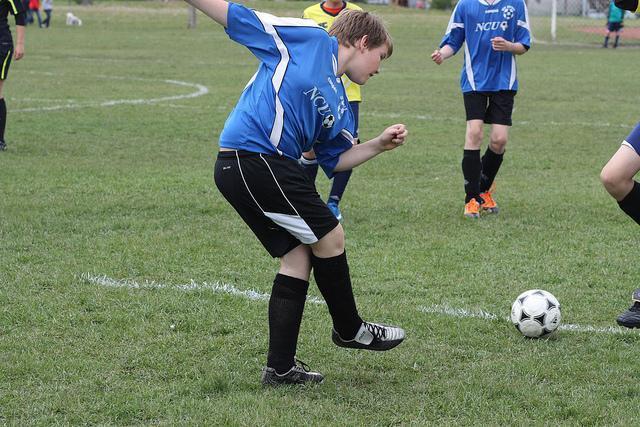How many team members with the yellow shirts can be seen?
Give a very brief answer. 1. How many team members with blue shirts can be seen?
Give a very brief answer. 2. How many balls are there?
Give a very brief answer. 1. How many people are there?
Give a very brief answer. 5. 